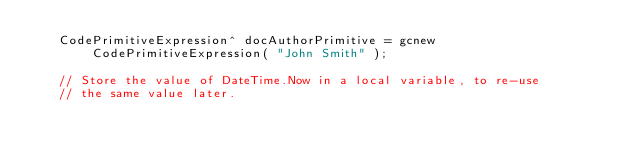<code> <loc_0><loc_0><loc_500><loc_500><_C++_>   CodePrimitiveExpression^ docAuthorPrimitive = gcnew CodePrimitiveExpression( "John Smith" );

   // Store the value of DateTime.Now in a local variable, to re-use
   // the same value later.</code> 